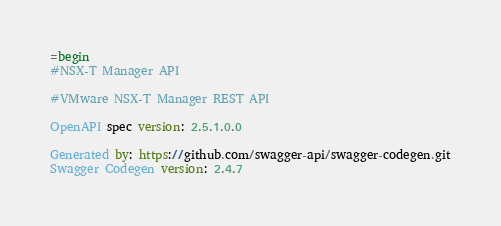Convert code to text. <code><loc_0><loc_0><loc_500><loc_500><_Ruby_>=begin
#NSX-T Manager API

#VMware NSX-T Manager REST API

OpenAPI spec version: 2.5.1.0.0

Generated by: https://github.com/swagger-api/swagger-codegen.git
Swagger Codegen version: 2.4.7
</code> 